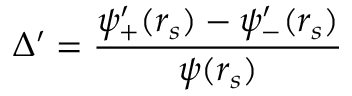Convert formula to latex. <formula><loc_0><loc_0><loc_500><loc_500>\Delta ^ { \prime } = \frac { \psi _ { + } ^ { \prime } ( r _ { s } ) - \psi _ { - } ^ { \prime } ( r _ { s } ) } { \psi ( r _ { s } ) }</formula> 